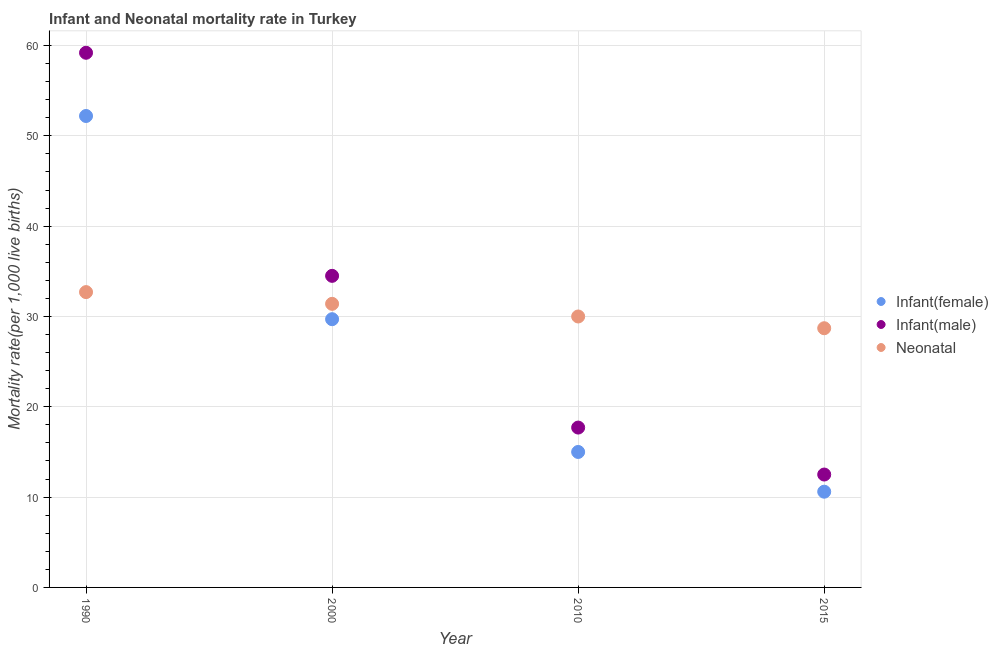What is the neonatal mortality rate in 1990?
Your answer should be compact. 32.7. Across all years, what is the maximum infant mortality rate(female)?
Keep it short and to the point. 52.2. Across all years, what is the minimum infant mortality rate(male)?
Keep it short and to the point. 12.5. In which year was the neonatal mortality rate minimum?
Make the answer very short. 2015. What is the total infant mortality rate(male) in the graph?
Your answer should be very brief. 123.9. What is the difference between the infant mortality rate(female) in 1990 and that in 2015?
Your answer should be very brief. 41.6. What is the average infant mortality rate(female) per year?
Keep it short and to the point. 26.88. In the year 1990, what is the difference between the infant mortality rate(male) and infant mortality rate(female)?
Offer a very short reply. 7. In how many years, is the neonatal mortality rate greater than 32?
Keep it short and to the point. 1. What is the ratio of the infant mortality rate(male) in 2000 to that in 2015?
Provide a short and direct response. 2.76. What is the difference between the highest and the second highest neonatal mortality rate?
Give a very brief answer. 1.3. What is the difference between the highest and the lowest infant mortality rate(female)?
Provide a short and direct response. 41.6. Is the sum of the infant mortality rate(male) in 1990 and 2010 greater than the maximum infant mortality rate(female) across all years?
Give a very brief answer. Yes. Does the infant mortality rate(male) monotonically increase over the years?
Give a very brief answer. No. How many dotlines are there?
Your answer should be very brief. 3. What is the difference between two consecutive major ticks on the Y-axis?
Your answer should be very brief. 10. How many legend labels are there?
Your answer should be very brief. 3. What is the title of the graph?
Give a very brief answer. Infant and Neonatal mortality rate in Turkey. What is the label or title of the Y-axis?
Offer a very short reply. Mortality rate(per 1,0 live births). What is the Mortality rate(per 1,000 live births) in Infant(female) in 1990?
Make the answer very short. 52.2. What is the Mortality rate(per 1,000 live births) of Infant(male) in 1990?
Give a very brief answer. 59.2. What is the Mortality rate(per 1,000 live births) of Neonatal  in 1990?
Provide a short and direct response. 32.7. What is the Mortality rate(per 1,000 live births) of Infant(female) in 2000?
Offer a terse response. 29.7. What is the Mortality rate(per 1,000 live births) in Infant(male) in 2000?
Your response must be concise. 34.5. What is the Mortality rate(per 1,000 live births) in Neonatal  in 2000?
Your answer should be very brief. 31.4. What is the Mortality rate(per 1,000 live births) in Infant(female) in 2010?
Offer a very short reply. 15. What is the Mortality rate(per 1,000 live births) in Infant(male) in 2015?
Provide a short and direct response. 12.5. What is the Mortality rate(per 1,000 live births) of Neonatal  in 2015?
Keep it short and to the point. 28.7. Across all years, what is the maximum Mortality rate(per 1,000 live births) of Infant(female)?
Your response must be concise. 52.2. Across all years, what is the maximum Mortality rate(per 1,000 live births) of Infant(male)?
Your response must be concise. 59.2. Across all years, what is the maximum Mortality rate(per 1,000 live births) in Neonatal ?
Offer a terse response. 32.7. Across all years, what is the minimum Mortality rate(per 1,000 live births) in Infant(male)?
Give a very brief answer. 12.5. Across all years, what is the minimum Mortality rate(per 1,000 live births) of Neonatal ?
Provide a short and direct response. 28.7. What is the total Mortality rate(per 1,000 live births) in Infant(female) in the graph?
Offer a terse response. 107.5. What is the total Mortality rate(per 1,000 live births) of Infant(male) in the graph?
Your answer should be very brief. 123.9. What is the total Mortality rate(per 1,000 live births) of Neonatal  in the graph?
Ensure brevity in your answer.  122.8. What is the difference between the Mortality rate(per 1,000 live births) in Infant(male) in 1990 and that in 2000?
Give a very brief answer. 24.7. What is the difference between the Mortality rate(per 1,000 live births) of Neonatal  in 1990 and that in 2000?
Ensure brevity in your answer.  1.3. What is the difference between the Mortality rate(per 1,000 live births) in Infant(female) in 1990 and that in 2010?
Your answer should be very brief. 37.2. What is the difference between the Mortality rate(per 1,000 live births) of Infant(male) in 1990 and that in 2010?
Give a very brief answer. 41.5. What is the difference between the Mortality rate(per 1,000 live births) of Neonatal  in 1990 and that in 2010?
Offer a very short reply. 2.7. What is the difference between the Mortality rate(per 1,000 live births) of Infant(female) in 1990 and that in 2015?
Offer a very short reply. 41.6. What is the difference between the Mortality rate(per 1,000 live births) of Infant(male) in 1990 and that in 2015?
Provide a short and direct response. 46.7. What is the difference between the Mortality rate(per 1,000 live births) of Infant(female) in 2000 and that in 2015?
Offer a terse response. 19.1. What is the difference between the Mortality rate(per 1,000 live births) of Neonatal  in 2000 and that in 2015?
Keep it short and to the point. 2.7. What is the difference between the Mortality rate(per 1,000 live births) in Infant(female) in 2010 and that in 2015?
Provide a succinct answer. 4.4. What is the difference between the Mortality rate(per 1,000 live births) in Infant(male) in 2010 and that in 2015?
Your answer should be compact. 5.2. What is the difference between the Mortality rate(per 1,000 live births) of Infant(female) in 1990 and the Mortality rate(per 1,000 live births) of Infant(male) in 2000?
Your response must be concise. 17.7. What is the difference between the Mortality rate(per 1,000 live births) in Infant(female) in 1990 and the Mortality rate(per 1,000 live births) in Neonatal  in 2000?
Your response must be concise. 20.8. What is the difference between the Mortality rate(per 1,000 live births) in Infant(male) in 1990 and the Mortality rate(per 1,000 live births) in Neonatal  in 2000?
Offer a terse response. 27.8. What is the difference between the Mortality rate(per 1,000 live births) of Infant(female) in 1990 and the Mortality rate(per 1,000 live births) of Infant(male) in 2010?
Provide a short and direct response. 34.5. What is the difference between the Mortality rate(per 1,000 live births) in Infant(male) in 1990 and the Mortality rate(per 1,000 live births) in Neonatal  in 2010?
Keep it short and to the point. 29.2. What is the difference between the Mortality rate(per 1,000 live births) in Infant(female) in 1990 and the Mortality rate(per 1,000 live births) in Infant(male) in 2015?
Provide a succinct answer. 39.7. What is the difference between the Mortality rate(per 1,000 live births) in Infant(male) in 1990 and the Mortality rate(per 1,000 live births) in Neonatal  in 2015?
Your response must be concise. 30.5. What is the difference between the Mortality rate(per 1,000 live births) in Infant(female) in 2000 and the Mortality rate(per 1,000 live births) in Infant(male) in 2010?
Offer a terse response. 12. What is the difference between the Mortality rate(per 1,000 live births) of Infant(female) in 2000 and the Mortality rate(per 1,000 live births) of Neonatal  in 2010?
Keep it short and to the point. -0.3. What is the difference between the Mortality rate(per 1,000 live births) in Infant(male) in 2000 and the Mortality rate(per 1,000 live births) in Neonatal  in 2010?
Offer a very short reply. 4.5. What is the difference between the Mortality rate(per 1,000 live births) in Infant(female) in 2000 and the Mortality rate(per 1,000 live births) in Infant(male) in 2015?
Your answer should be compact. 17.2. What is the difference between the Mortality rate(per 1,000 live births) of Infant(female) in 2000 and the Mortality rate(per 1,000 live births) of Neonatal  in 2015?
Give a very brief answer. 1. What is the difference between the Mortality rate(per 1,000 live births) in Infant(male) in 2000 and the Mortality rate(per 1,000 live births) in Neonatal  in 2015?
Your answer should be very brief. 5.8. What is the difference between the Mortality rate(per 1,000 live births) in Infant(female) in 2010 and the Mortality rate(per 1,000 live births) in Neonatal  in 2015?
Offer a terse response. -13.7. What is the difference between the Mortality rate(per 1,000 live births) in Infant(male) in 2010 and the Mortality rate(per 1,000 live births) in Neonatal  in 2015?
Your answer should be compact. -11. What is the average Mortality rate(per 1,000 live births) in Infant(female) per year?
Offer a terse response. 26.88. What is the average Mortality rate(per 1,000 live births) in Infant(male) per year?
Your response must be concise. 30.98. What is the average Mortality rate(per 1,000 live births) of Neonatal  per year?
Give a very brief answer. 30.7. In the year 2010, what is the difference between the Mortality rate(per 1,000 live births) in Infant(female) and Mortality rate(per 1,000 live births) in Infant(male)?
Your answer should be compact. -2.7. In the year 2015, what is the difference between the Mortality rate(per 1,000 live births) of Infant(female) and Mortality rate(per 1,000 live births) of Infant(male)?
Your answer should be very brief. -1.9. In the year 2015, what is the difference between the Mortality rate(per 1,000 live births) in Infant(female) and Mortality rate(per 1,000 live births) in Neonatal ?
Make the answer very short. -18.1. In the year 2015, what is the difference between the Mortality rate(per 1,000 live births) in Infant(male) and Mortality rate(per 1,000 live births) in Neonatal ?
Make the answer very short. -16.2. What is the ratio of the Mortality rate(per 1,000 live births) of Infant(female) in 1990 to that in 2000?
Provide a succinct answer. 1.76. What is the ratio of the Mortality rate(per 1,000 live births) in Infant(male) in 1990 to that in 2000?
Offer a very short reply. 1.72. What is the ratio of the Mortality rate(per 1,000 live births) of Neonatal  in 1990 to that in 2000?
Keep it short and to the point. 1.04. What is the ratio of the Mortality rate(per 1,000 live births) of Infant(female) in 1990 to that in 2010?
Provide a succinct answer. 3.48. What is the ratio of the Mortality rate(per 1,000 live births) in Infant(male) in 1990 to that in 2010?
Make the answer very short. 3.34. What is the ratio of the Mortality rate(per 1,000 live births) of Neonatal  in 1990 to that in 2010?
Provide a short and direct response. 1.09. What is the ratio of the Mortality rate(per 1,000 live births) of Infant(female) in 1990 to that in 2015?
Ensure brevity in your answer.  4.92. What is the ratio of the Mortality rate(per 1,000 live births) in Infant(male) in 1990 to that in 2015?
Keep it short and to the point. 4.74. What is the ratio of the Mortality rate(per 1,000 live births) of Neonatal  in 1990 to that in 2015?
Give a very brief answer. 1.14. What is the ratio of the Mortality rate(per 1,000 live births) in Infant(female) in 2000 to that in 2010?
Provide a succinct answer. 1.98. What is the ratio of the Mortality rate(per 1,000 live births) in Infant(male) in 2000 to that in 2010?
Your answer should be very brief. 1.95. What is the ratio of the Mortality rate(per 1,000 live births) of Neonatal  in 2000 to that in 2010?
Your answer should be very brief. 1.05. What is the ratio of the Mortality rate(per 1,000 live births) of Infant(female) in 2000 to that in 2015?
Give a very brief answer. 2.8. What is the ratio of the Mortality rate(per 1,000 live births) in Infant(male) in 2000 to that in 2015?
Your response must be concise. 2.76. What is the ratio of the Mortality rate(per 1,000 live births) in Neonatal  in 2000 to that in 2015?
Keep it short and to the point. 1.09. What is the ratio of the Mortality rate(per 1,000 live births) of Infant(female) in 2010 to that in 2015?
Your answer should be compact. 1.42. What is the ratio of the Mortality rate(per 1,000 live births) in Infant(male) in 2010 to that in 2015?
Offer a very short reply. 1.42. What is the ratio of the Mortality rate(per 1,000 live births) of Neonatal  in 2010 to that in 2015?
Give a very brief answer. 1.05. What is the difference between the highest and the second highest Mortality rate(per 1,000 live births) in Infant(female)?
Give a very brief answer. 22.5. What is the difference between the highest and the second highest Mortality rate(per 1,000 live births) of Infant(male)?
Make the answer very short. 24.7. What is the difference between the highest and the lowest Mortality rate(per 1,000 live births) of Infant(female)?
Your answer should be very brief. 41.6. What is the difference between the highest and the lowest Mortality rate(per 1,000 live births) of Infant(male)?
Offer a terse response. 46.7. What is the difference between the highest and the lowest Mortality rate(per 1,000 live births) in Neonatal ?
Your answer should be very brief. 4. 